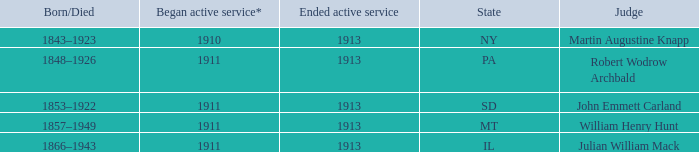Give me the full table as a dictionary. {'header': ['Born/Died', 'Began active service*', 'Ended active service', 'State', 'Judge'], 'rows': [['1843–1923', '1910', '1913', 'NY', 'Martin Augustine Knapp'], ['1848–1926', '1911', '1913', 'PA', 'Robert Wodrow Archbald'], ['1853–1922', '1911', '1913', 'SD', 'John Emmett Carland'], ['1857–1949', '1911', '1913', 'MT', 'William Henry Hunt'], ['1866–1943', '1911', '1913', 'IL', 'Julian William Mack']]} Who was the judge for the state SD? John Emmett Carland. 